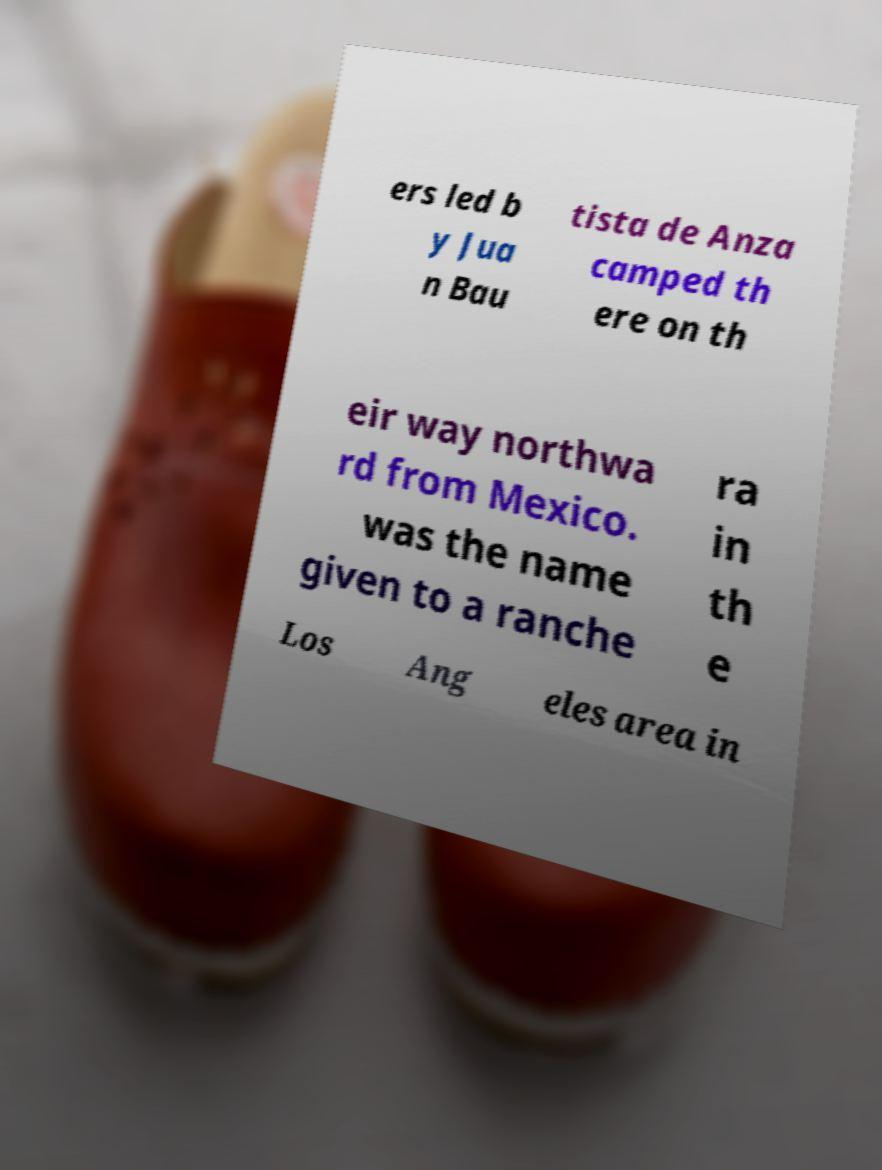Can you accurately transcribe the text from the provided image for me? ers led b y Jua n Bau tista de Anza camped th ere on th eir way northwa rd from Mexico. was the name given to a ranche ra in th e Los Ang eles area in 